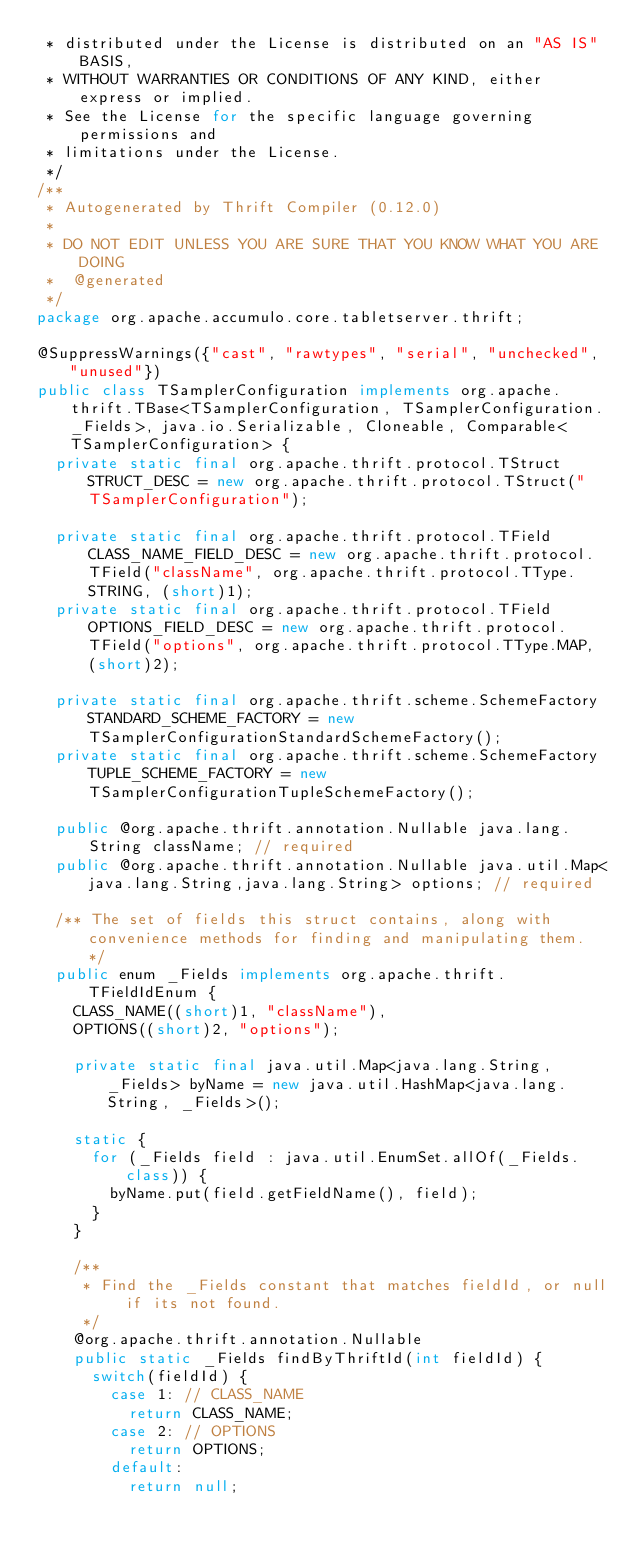Convert code to text. <code><loc_0><loc_0><loc_500><loc_500><_Java_> * distributed under the License is distributed on an "AS IS" BASIS,
 * WITHOUT WARRANTIES OR CONDITIONS OF ANY KIND, either express or implied.
 * See the License for the specific language governing permissions and
 * limitations under the License.
 */
/**
 * Autogenerated by Thrift Compiler (0.12.0)
 *
 * DO NOT EDIT UNLESS YOU ARE SURE THAT YOU KNOW WHAT YOU ARE DOING
 *  @generated
 */
package org.apache.accumulo.core.tabletserver.thrift;

@SuppressWarnings({"cast", "rawtypes", "serial", "unchecked", "unused"})
public class TSamplerConfiguration implements org.apache.thrift.TBase<TSamplerConfiguration, TSamplerConfiguration._Fields>, java.io.Serializable, Cloneable, Comparable<TSamplerConfiguration> {
  private static final org.apache.thrift.protocol.TStruct STRUCT_DESC = new org.apache.thrift.protocol.TStruct("TSamplerConfiguration");

  private static final org.apache.thrift.protocol.TField CLASS_NAME_FIELD_DESC = new org.apache.thrift.protocol.TField("className", org.apache.thrift.protocol.TType.STRING, (short)1);
  private static final org.apache.thrift.protocol.TField OPTIONS_FIELD_DESC = new org.apache.thrift.protocol.TField("options", org.apache.thrift.protocol.TType.MAP, (short)2);

  private static final org.apache.thrift.scheme.SchemeFactory STANDARD_SCHEME_FACTORY = new TSamplerConfigurationStandardSchemeFactory();
  private static final org.apache.thrift.scheme.SchemeFactory TUPLE_SCHEME_FACTORY = new TSamplerConfigurationTupleSchemeFactory();

  public @org.apache.thrift.annotation.Nullable java.lang.String className; // required
  public @org.apache.thrift.annotation.Nullable java.util.Map<java.lang.String,java.lang.String> options; // required

  /** The set of fields this struct contains, along with convenience methods for finding and manipulating them. */
  public enum _Fields implements org.apache.thrift.TFieldIdEnum {
    CLASS_NAME((short)1, "className"),
    OPTIONS((short)2, "options");

    private static final java.util.Map<java.lang.String, _Fields> byName = new java.util.HashMap<java.lang.String, _Fields>();

    static {
      for (_Fields field : java.util.EnumSet.allOf(_Fields.class)) {
        byName.put(field.getFieldName(), field);
      }
    }

    /**
     * Find the _Fields constant that matches fieldId, or null if its not found.
     */
    @org.apache.thrift.annotation.Nullable
    public static _Fields findByThriftId(int fieldId) {
      switch(fieldId) {
        case 1: // CLASS_NAME
          return CLASS_NAME;
        case 2: // OPTIONS
          return OPTIONS;
        default:
          return null;</code> 